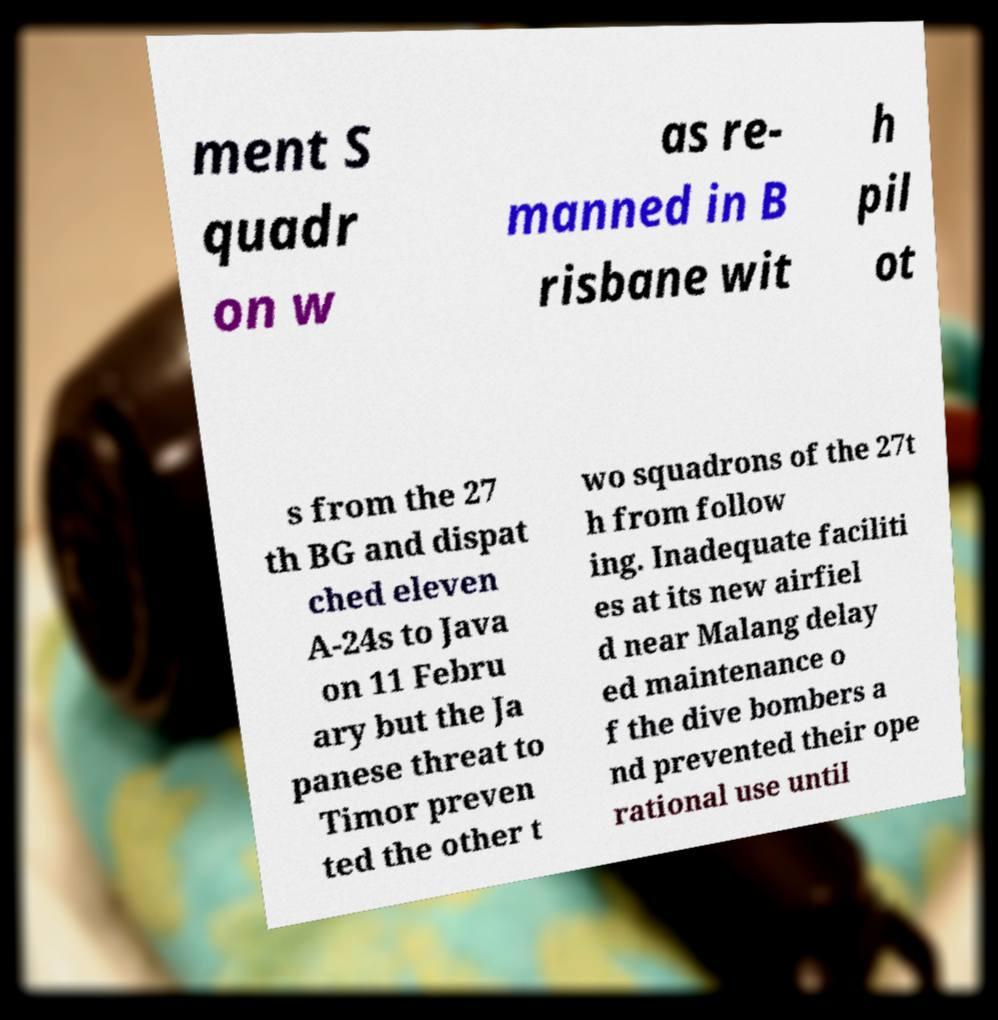I need the written content from this picture converted into text. Can you do that? ment S quadr on w as re- manned in B risbane wit h pil ot s from the 27 th BG and dispat ched eleven A-24s to Java on 11 Febru ary but the Ja panese threat to Timor preven ted the other t wo squadrons of the 27t h from follow ing. Inadequate faciliti es at its new airfiel d near Malang delay ed maintenance o f the dive bombers a nd prevented their ope rational use until 